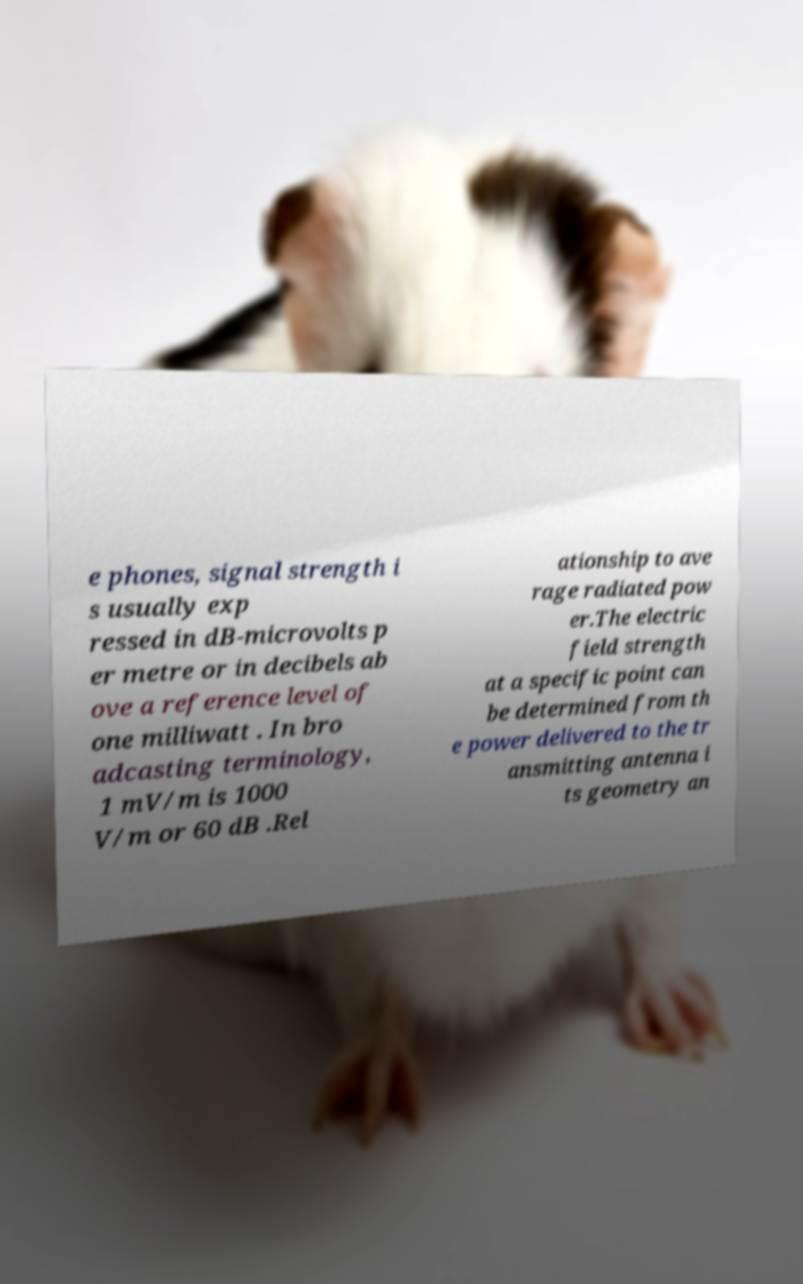I need the written content from this picture converted into text. Can you do that? e phones, signal strength i s usually exp ressed in dB-microvolts p er metre or in decibels ab ove a reference level of one milliwatt . In bro adcasting terminology, 1 mV/m is 1000 V/m or 60 dB .Rel ationship to ave rage radiated pow er.The electric field strength at a specific point can be determined from th e power delivered to the tr ansmitting antenna i ts geometry an 